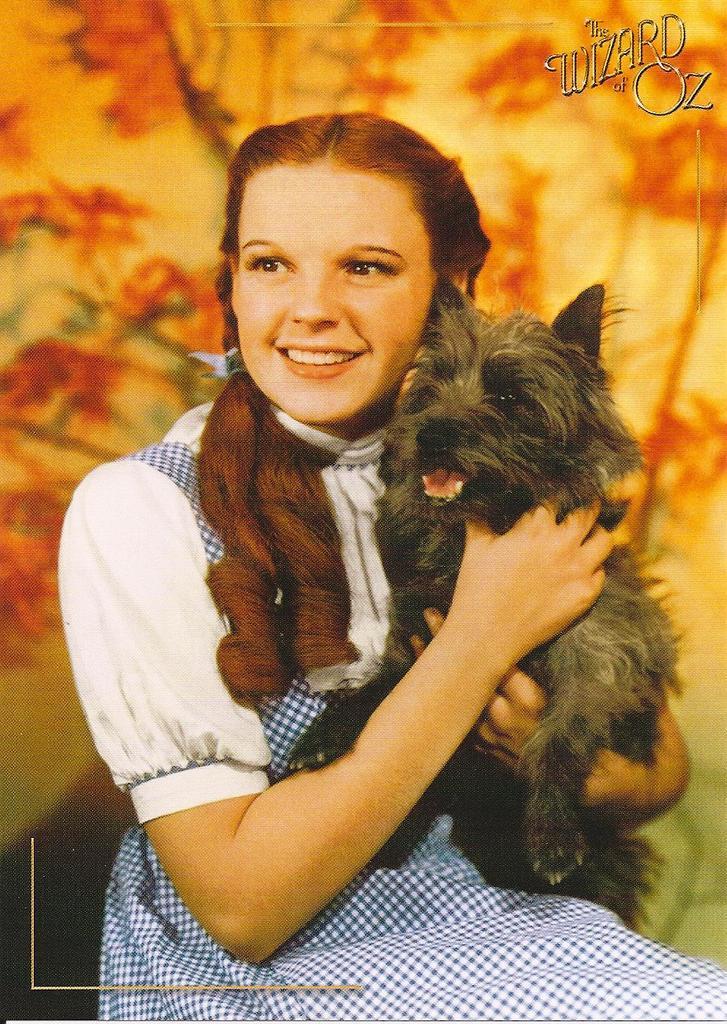Could you give a brief overview of what you see in this image? In this image we can see a girl is holding a dog in her hands. In the background we can see designs on a platform and at the top there are texts written on the image. 